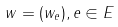<formula> <loc_0><loc_0><loc_500><loc_500>w = ( w _ { e } ) , e \in E</formula> 